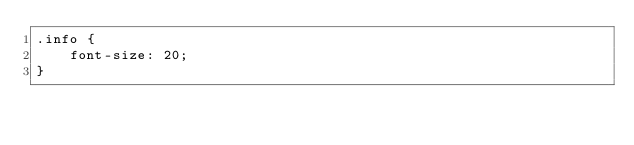<code> <loc_0><loc_0><loc_500><loc_500><_CSS_>.info {
    font-size: 20;
}</code> 